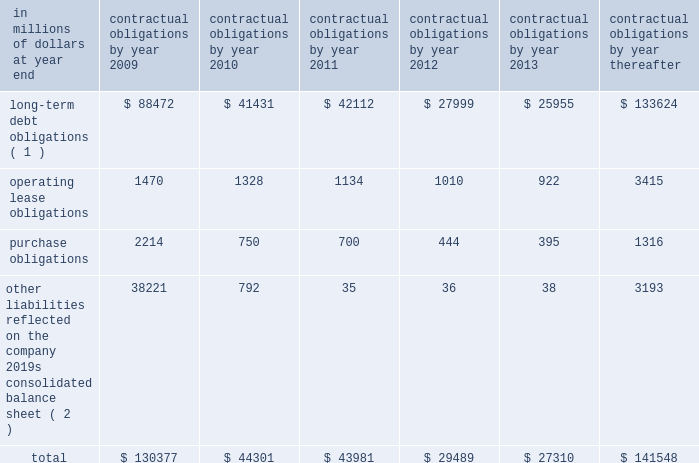Contractual obligations the table includes aggregated information about citigroup 2019s contractual obligations that impact its short- and long-term liquidity and capital needs .
The table includes information about payments due under specified contractual obligations , aggregated by type of contractual obligation .
It includes the maturity profile of the company 2019s consolidated long-term debt , operating leases and other long-term liabilities .
The company 2019s capital lease obligations are included in purchase obligations in the table .
Citigroup 2019s contractual obligations include purchase obligations that are enforceable and legally binding for the company .
For the purposes of the table below , purchase obligations are included through the termination date of the respective agreements , even if the contract is renewable .
Many of the purchase agreements for goods or services include clauses that would allow the company to cancel the agreement with specified notice ; however , that impact is not included in the table ( unless citigroup has already notified the counterparty of its intention to terminate the agreement ) .
Other liabilities reflected on the company 2019s consolidated balance sheet include obligations for goods and services that have already been received , litigation settlements , uncertain tax positions , as well as other long-term liabilities that have been incurred and will ultimately be paid in cash .
Excluded from the table are obligations that are generally short term in nature , including deposit liabilities and securities sold under agreements to repurchase .
The table also excludes certain insurance and investment contracts subject to mortality and morbidity risks or without defined maturities , such that the timing of payments and withdrawals is uncertain .
The liabilities related to these insurance and investment contracts are included on the consolidated balance sheet as insurance policy and claims reserves , contractholder funds , and separate and variable accounts .
Citigroup 2019s funding policy for pension plans is generally to fund to the minimum amounts required by the applicable laws and regulations .
At december 31 , 2008 , there were no minimum required contributions , and no contributions are currently planned for the u.s .
Pension plans .
Accordingly , no amounts have been included in the table below for future contributions to the u.s .
Pension plans .
For the non-u.s .
Plans , discretionary contributions in 2009 are anticipated to be approximately $ 167 million and this amount has been included in purchase obligations in the table below .
The estimated pension plan contributions are subject to change , since contribution decisions are affected by various factors , such as market performance , regulatory and legal requirements , and management 2019s ability to change funding policy .
For additional information regarding the company 2019s retirement benefit obligations , see note 9 to the consolidated financial statements on page 144. .
( 1 ) for additional information about long-term debt and trust preferred securities , see note 20 to the consolidated financial statements on page 169 .
( 2 ) relates primarily to accounts payable and accrued expenses included in other liabilities in the company 2019s consolidated balance sheet .
Also included are various litigation settlements. .
What percentage of total contractual obligations due in 2010 are comprised of long-term debt obligations? 
Computations: (41431 / 44301)
Answer: 0.93522. 